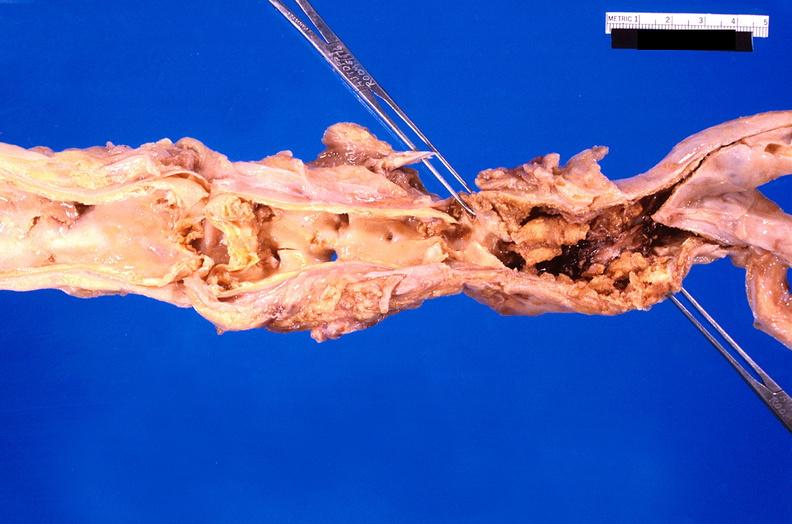what does this image show?
Answer the question using a single word or phrase. Abdominal aorta saccular aneurysm 